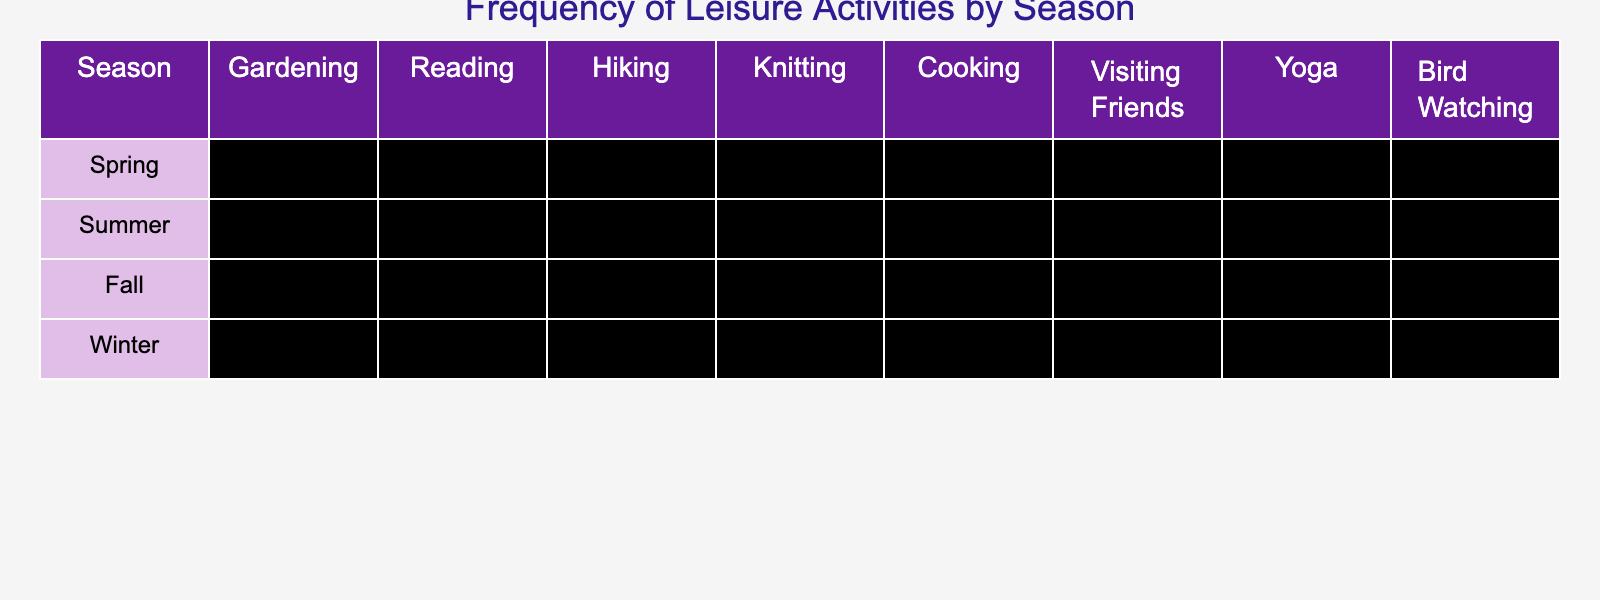What leisure activity has the highest frequency in Spring? In the Spring row, we can look at the values for each activity. The highest number is 4 for Reading and Bird Watching.
Answer: Reading and Bird Watching Which season has the lowest frequency for Gardening? In the Gardening column, looking at the seasons, Winter has a frequency of 0, which is the lowest.
Answer: Winter What is the average frequency of Cooking across all seasons? To find the average frequency of Cooking, add the values for Cooking across all seasons (3 + 2 + 4 + 5 = 14) and divide by the number of seasons (4). So, 14/4 = 3.5.
Answer: 3.5 During which season is Knitting most popular? Looking at the Knitting column, the highest frequency is found in Winter, where the value is 5.
Answer: Winter Is the frequency of Yoga higher in Summer than in Spring? Yoga has a frequency of 3 in both Summer and Spring. Since they are equal, the answer is no.
Answer: No What is the total frequency of Bird Watching in the Fall and Winter? For Bird Watching, the frequency in Fall is 2 and in Winter is 1. Adding these together gives 2 + 1 = 3.
Answer: 3 Which leisure activity shows the most consistent frequency across the seasons? By examining the values for each activity across seasons, Reading has frequencies of 4, 3, 5, and 5, varying from 3 to 5. It seems to have the least change.
Answer: Reading What season has the highest total frequency of leisure activities? To find the total frequency for each season, sum the values: Spring (3+4+2+1+3+2+3+4=22), Summer (4+3+4+1+2+4+3+3=24), Fall (2+5+3+2+4+3+2+2=23), Winter (0+5+1+5+5+2+4+1=23). Summer has the highest total of 24.
Answer: Summer Is it true that there are more activities with a frequency of 4 or higher in Fall than in Spring? In Fall, there are 3 activities (Reading, Cooking, and Yoga) with a frequency of 4 or higher, while in Spring, there are also 3 (Reading, Bird Watching, and Cooking). Therefore, it is not true.
Answer: No What is the difference in frequency of Hiking between Spring and Summer? In Spring, Hiking has a frequency of 2 and in Summer, it has a frequency of 4. The difference is 4 - 2 = 2.
Answer: 2 